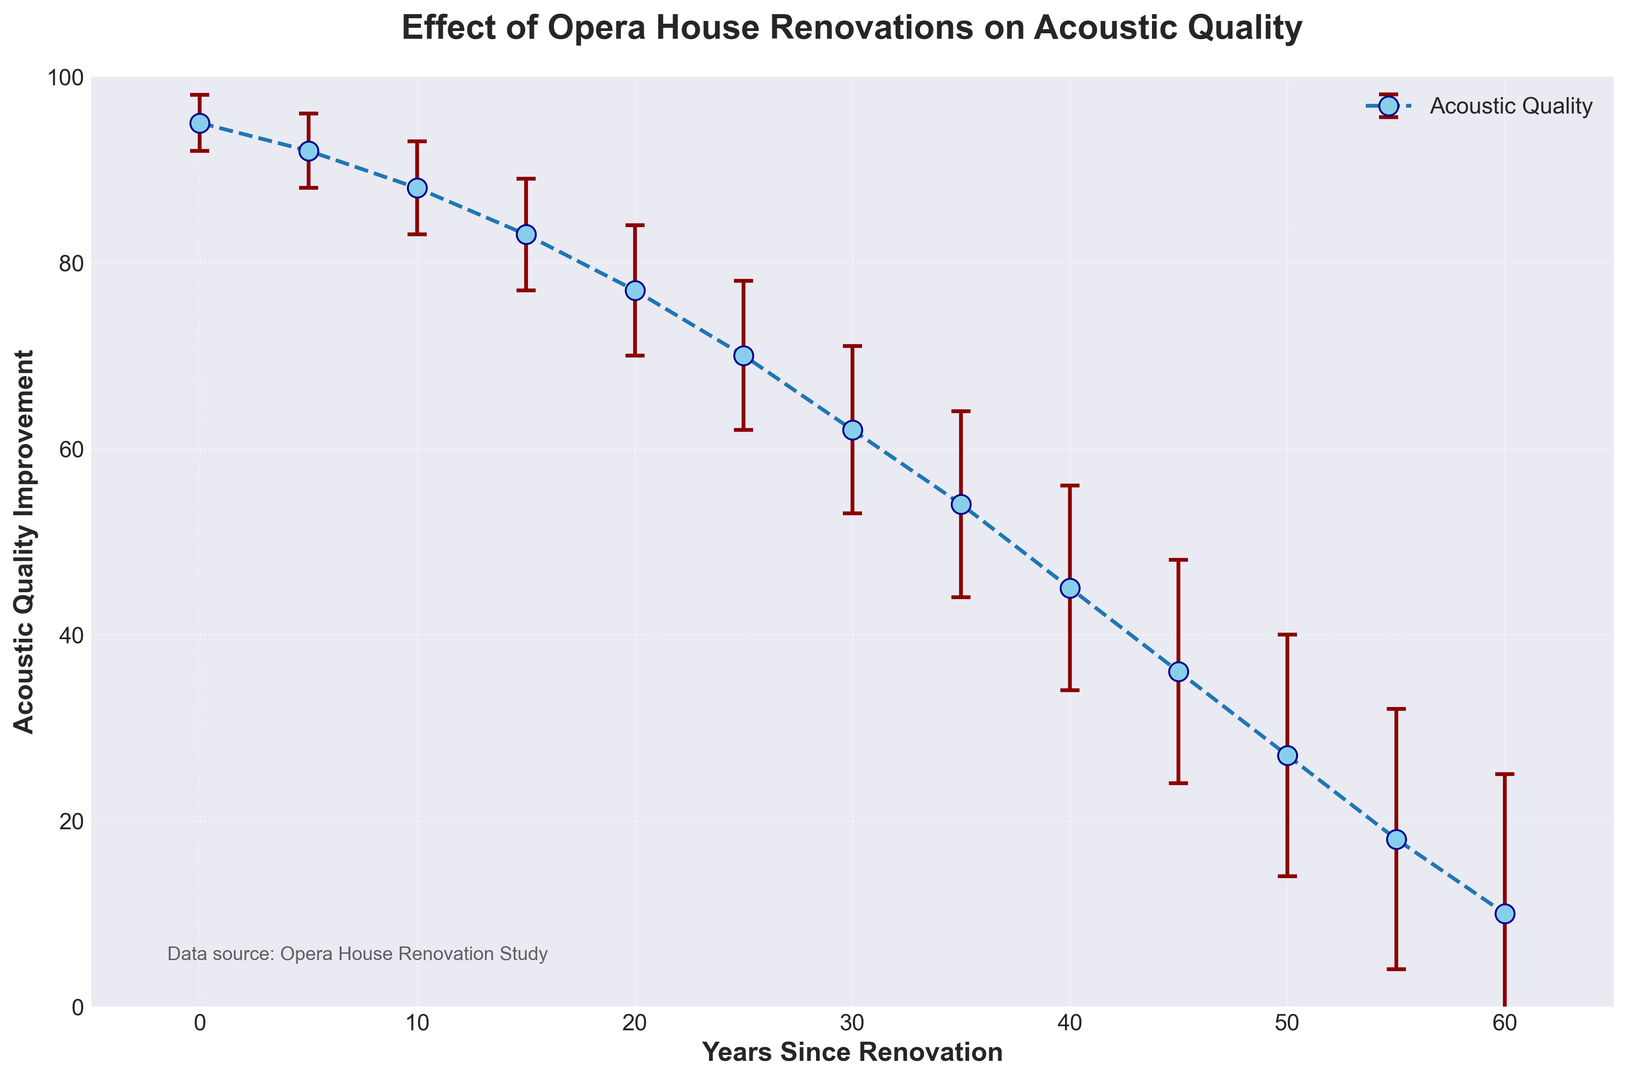What is the acoustic quality improvement immediately after renovation? Look at the data point corresponding to 0 years since renovation. The y-axis value for this point represents the acoustic quality improvement immediately after renovation.
Answer: 95 What is the difference in acoustic quality improvement between 10 years and 30 years since renovation? Find the acoustic quality improvement values for both 10 years and 30 years since renovation. The values are 88 and 62, respectively. Subtract the latter from the former: 88 - 62.
Answer: 26 By how much does the uncertainty range increase from 5 years since renovation to 40 years since renovation? The uncertainty range for 5 years since renovation is 4, and for 40 years since renovation, it is 11. Subtract the former from the latter: 11 - 4.
Answer: 7 Which data point has the highest uncertainty and what is its corresponding acoustic quality improvement? The data point with the highest uncertainty can be found by looking for the largest error bar. This corresponds to 60 years since renovation with an acoustic quality improvement value of 10.
Answer: 60 years, 10 What is the trend of acoustic quality improvement as the years since renovation increase? Observe the plotted line and error bars on the graph. The acoustic quality improvement decreases steadily as the years since renovation increase.
Answer: Decreasing What is the approximate acoustic quality improvement at 25 years since renovation, and how uncertain is this measurement? Look at the data point corresponding to 25 years since renovation. The acoustic quality improvement is about 70, and the uncertainty is 8.
Answer: 70, 8 How does the acoustic quality at 35 years since renovation compare to 15 years since renovation? Find the acoustic quality improvement values for 35 and 15 years since renovation. The values are 54 and 83, respectively. Compare these values to see that acoustic quality at 35 years is lower than at 15 years.
Answer: Lower What is the general relationship between the amplitude of the error bars and the number of years since renovation? Observe the lengths of the error bars in relation to the years since renovation. The error bars tend to increase in length as the number of years since renovation increases.
Answer: Increase What is the drop in acoustic quality improvement from 0 years to 50 years since renovation? Find the acoustic quality improvement values for 0 years and 50 years since renovation. The values are 95 and 27, respectively. Subtract the latter from the former: 95 - 27.
Answer: 68 Is there any year since renovation where the acoustic quality improvement is approximately in the middle of the y-axis range (i.e., around 50)? Scan the y-axis values for a point that is approximately 50. The nearest point is for 35 years since renovation with an acoustic quality improvement of 54.
Answer: 35 years 